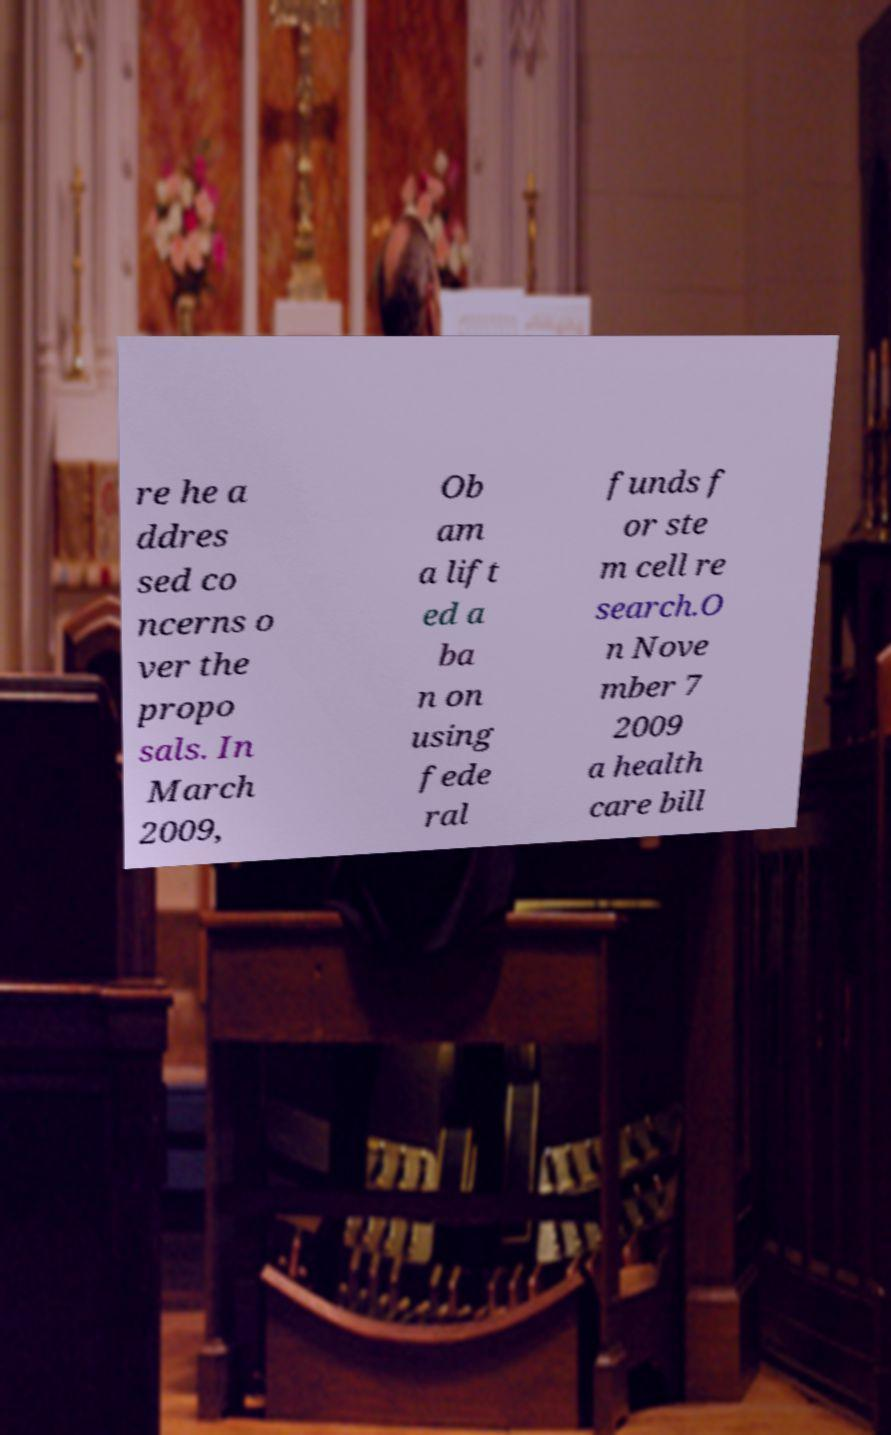Can you accurately transcribe the text from the provided image for me? re he a ddres sed co ncerns o ver the propo sals. In March 2009, Ob am a lift ed a ba n on using fede ral funds f or ste m cell re search.O n Nove mber 7 2009 a health care bill 